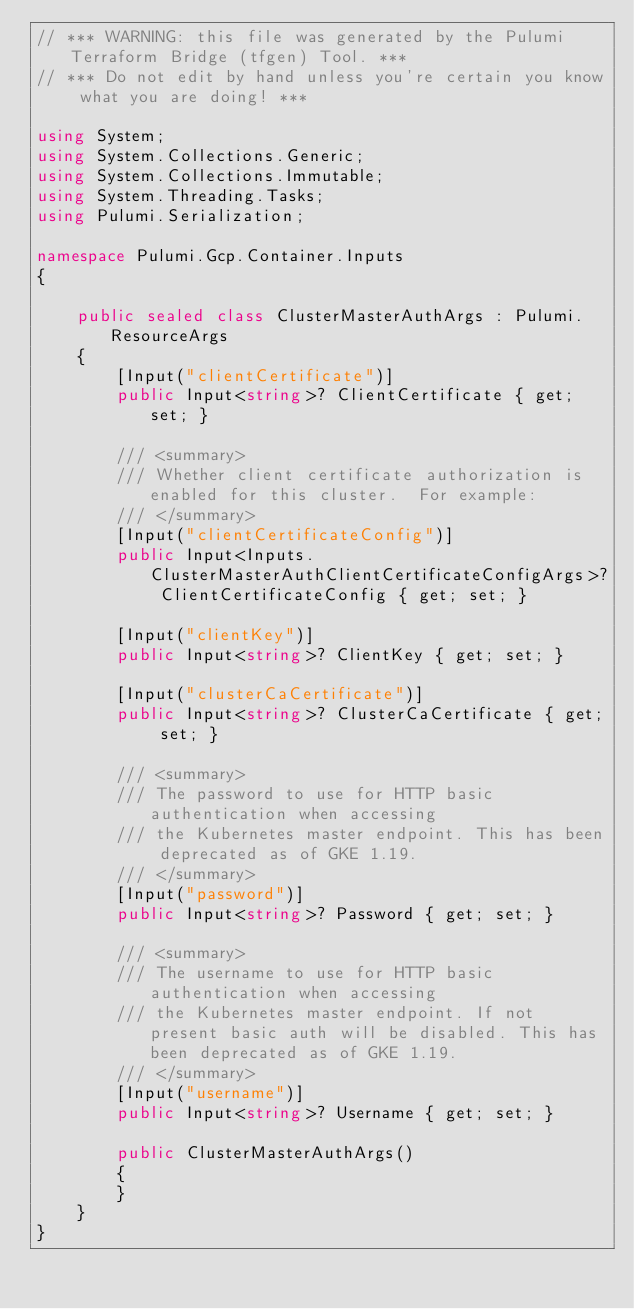<code> <loc_0><loc_0><loc_500><loc_500><_C#_>// *** WARNING: this file was generated by the Pulumi Terraform Bridge (tfgen) Tool. ***
// *** Do not edit by hand unless you're certain you know what you are doing! ***

using System;
using System.Collections.Generic;
using System.Collections.Immutable;
using System.Threading.Tasks;
using Pulumi.Serialization;

namespace Pulumi.Gcp.Container.Inputs
{

    public sealed class ClusterMasterAuthArgs : Pulumi.ResourceArgs
    {
        [Input("clientCertificate")]
        public Input<string>? ClientCertificate { get; set; }

        /// <summary>
        /// Whether client certificate authorization is enabled for this cluster.  For example:
        /// </summary>
        [Input("clientCertificateConfig")]
        public Input<Inputs.ClusterMasterAuthClientCertificateConfigArgs>? ClientCertificateConfig { get; set; }

        [Input("clientKey")]
        public Input<string>? ClientKey { get; set; }

        [Input("clusterCaCertificate")]
        public Input<string>? ClusterCaCertificate { get; set; }

        /// <summary>
        /// The password to use for HTTP basic authentication when accessing
        /// the Kubernetes master endpoint. This has been deprecated as of GKE 1.19.
        /// </summary>
        [Input("password")]
        public Input<string>? Password { get; set; }

        /// <summary>
        /// The username to use for HTTP basic authentication when accessing
        /// the Kubernetes master endpoint. If not present basic auth will be disabled. This has been deprecated as of GKE 1.19.
        /// </summary>
        [Input("username")]
        public Input<string>? Username { get; set; }

        public ClusterMasterAuthArgs()
        {
        }
    }
}
</code> 